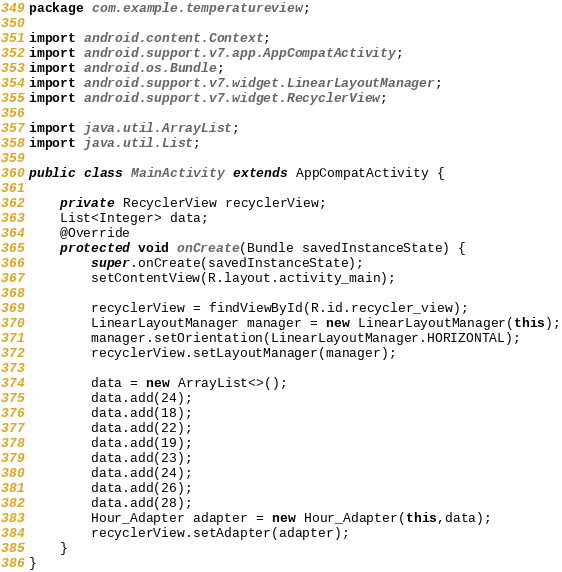<code> <loc_0><loc_0><loc_500><loc_500><_Java_>package com.example.temperatureview;

import android.content.Context;
import android.support.v7.app.AppCompatActivity;
import android.os.Bundle;
import android.support.v7.widget.LinearLayoutManager;
import android.support.v7.widget.RecyclerView;

import java.util.ArrayList;
import java.util.List;

public class MainActivity extends AppCompatActivity {

    private RecyclerView recyclerView;
    List<Integer> data;
    @Override
    protected void onCreate(Bundle savedInstanceState) {
        super.onCreate(savedInstanceState);
        setContentView(R.layout.activity_main);

        recyclerView = findViewById(R.id.recycler_view);
        LinearLayoutManager manager = new LinearLayoutManager(this);
        manager.setOrientation(LinearLayoutManager.HORIZONTAL);
        recyclerView.setLayoutManager(manager);

        data = new ArrayList<>();
        data.add(24);
        data.add(18);
        data.add(22);
        data.add(19);
        data.add(23);
        data.add(24);
        data.add(26);
        data.add(28);
        Hour_Adapter adapter = new Hour_Adapter(this,data);
        recyclerView.setAdapter(adapter);
    }
}
</code> 